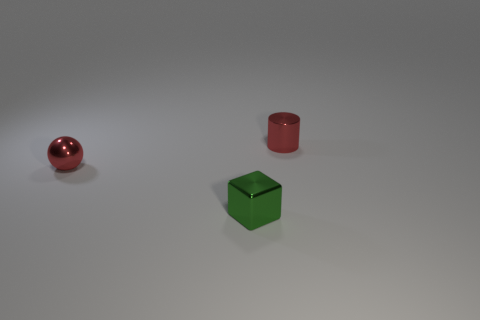Add 3 large rubber spheres. How many objects exist? 6 Subtract all blocks. How many objects are left? 2 Subtract all red cylinders. Subtract all green blocks. How many objects are left? 1 Add 2 metal spheres. How many metal spheres are left? 3 Add 3 green metallic things. How many green metallic things exist? 4 Subtract 0 yellow balls. How many objects are left? 3 Subtract all red blocks. Subtract all red cylinders. How many blocks are left? 1 